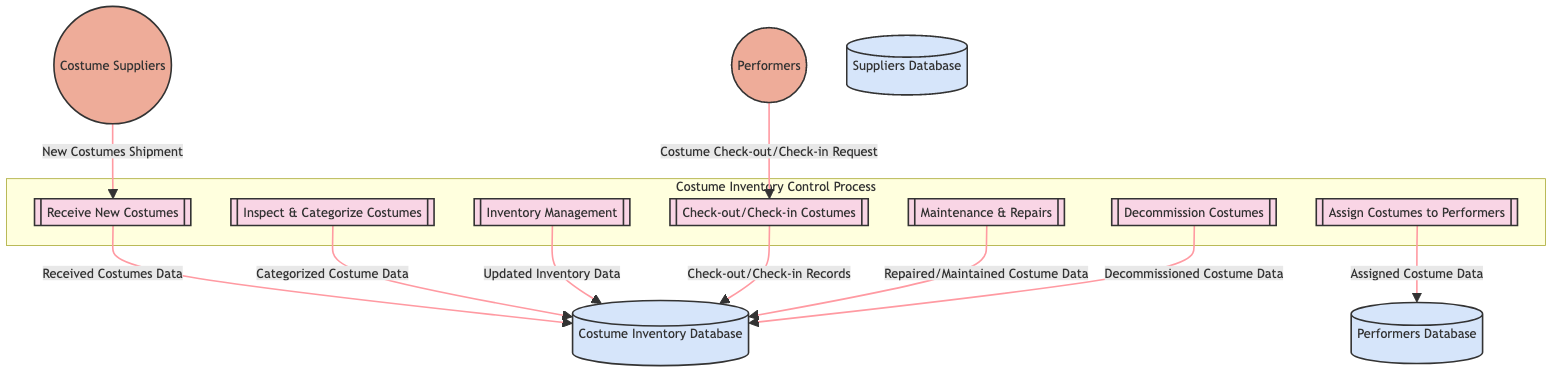What is the first process in the Costume Inventory Control Process? The first process listed in the diagram is "Receive New Costumes." It is identified at the top of the process flow and serves as the starting point for the inventory control activities.
Answer: Receive New Costumes How many processes are there in the Costume Inventory Control Process? By counting all the distinct processes in the diagram, there are a total of seven processes listed. Each process is detailed in the diagram and flows into one another.
Answer: 7 Which database stores the assigned costume data? The "Performers Database" stores the assigned costume data, as indicated by the flow from the "Assign Costumes to Performers" process to the database labeled D2.
Answer: Performers Database What is the flow of data from the "Check-out/Check-in Costumes" process? The data flows from the "Check-out/Check-in Costumes" process to the "Costume Inventory Database." This indicates that the records of checked-out and checked-in costumes are stored in the database.
Answer: Check-out/Check-in Records What is the relationship between the "Inspect & Categorize Costumes" process and the "Costume Inventory Database"? The relationship is that the "Inspect & Categorize Costumes" process produces "Categorized Costume Data," which is then sent to the "Costume Inventory Database," indicating a data flow for storage and tracking categorized costumes.
Answer: Categorized Costume Data Which external entity receives costumes for performances? The external entity that receives costumes for performances is "Performers." This entity represents the ballet dancers who both check out and return costumes for rehearsals and performances.
Answer: Performers What happens to costumes that are no longer usable? The process named "Decommission Costumes" handles costumes that are no longer usable, sending "Decommissioned Costume Data" to the "Costume Inventory Database" to track their lifecycle.
Answer: Decommissioned Costume Data 